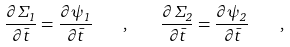Convert formula to latex. <formula><loc_0><loc_0><loc_500><loc_500>\frac { \partial \Sigma _ { 1 } } { \partial \bar { t } } = \frac { \partial \psi _ { 1 } } { \partial \bar { t } } \quad , \quad \frac { \partial \Sigma _ { 2 } } { \partial \bar { t } } = \frac { \partial \psi _ { 2 } } { \partial \bar { t } } \quad ,</formula> 